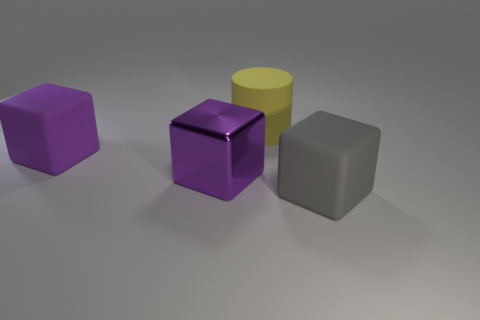Can you describe the arrangement of objects in this image? Absolutely, the image presents a collection of geometric objects on a flat surface. From left to right, there's a purple cube, a purple metal cube with a reflective surface, a small yellow cylinder, and a larger grey cube partially obscured by the purple metal cube. What can you tell me about the lighting and shadows? The lighting in the image creates soft shadows for each object, suggesting a diffused light source above and to the right. The shadows help to provide a sense of depth and position, indicating that the light source is not directly overhead but rather at an angle. 